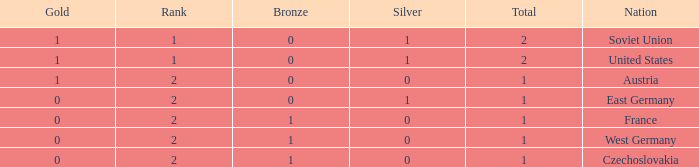What is the total number of bronze medals of West Germany, which is ranked 2 and has less than 1 total medals? 0.0. 